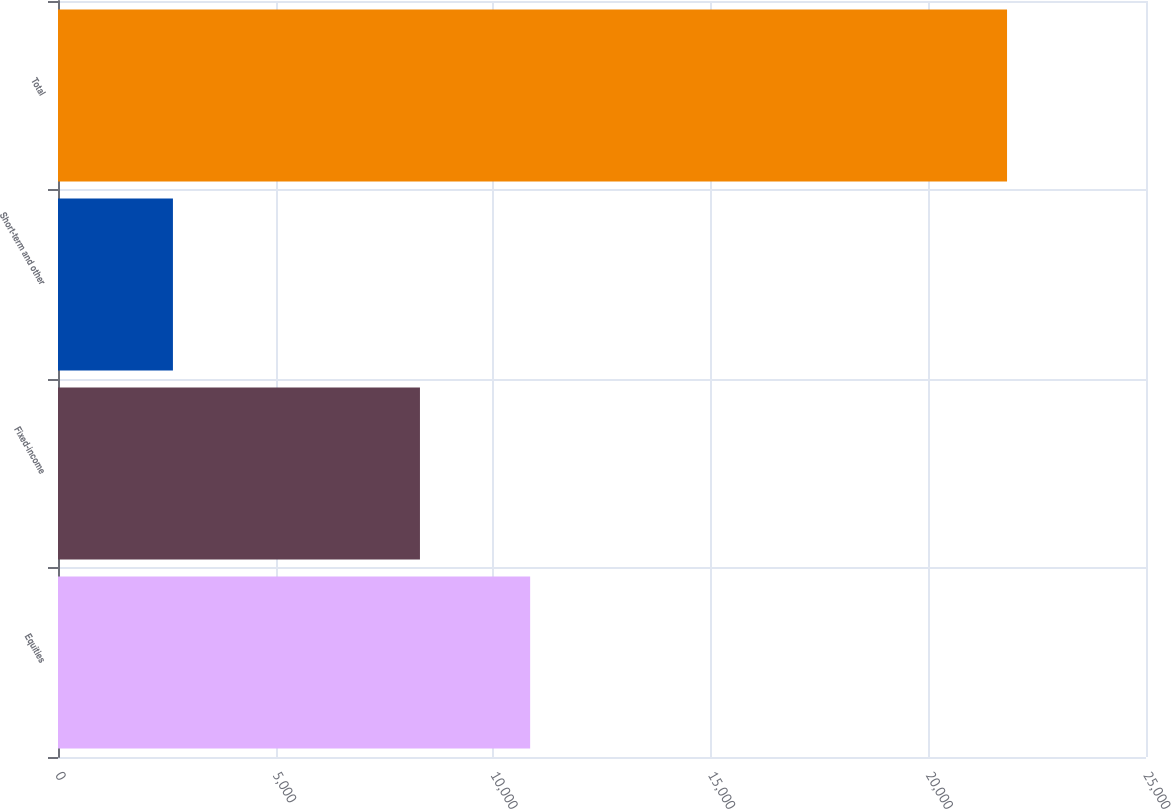Convert chart to OTSL. <chart><loc_0><loc_0><loc_500><loc_500><bar_chart><fcel>Equities<fcel>Fixed-income<fcel>Short-term and other<fcel>Total<nl><fcel>10849<fcel>8317<fcel>2641<fcel>21807<nl></chart> 